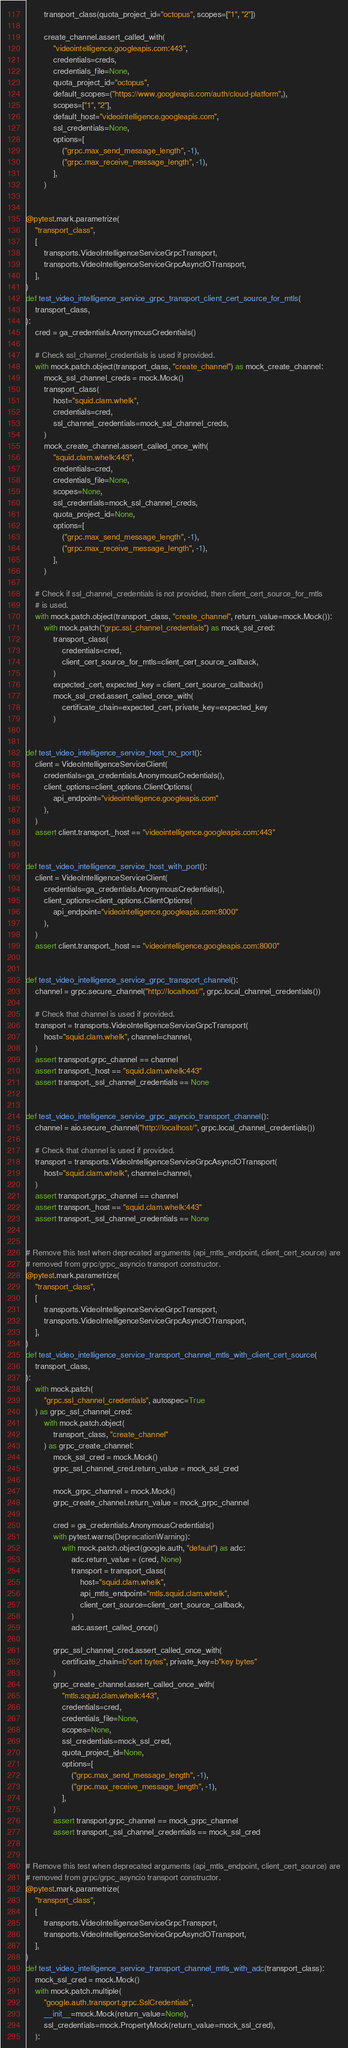Convert code to text. <code><loc_0><loc_0><loc_500><loc_500><_Python_>        transport_class(quota_project_id="octopus", scopes=["1", "2"])

        create_channel.assert_called_with(
            "videointelligence.googleapis.com:443",
            credentials=creds,
            credentials_file=None,
            quota_project_id="octopus",
            default_scopes=("https://www.googleapis.com/auth/cloud-platform",),
            scopes=["1", "2"],
            default_host="videointelligence.googleapis.com",
            ssl_credentials=None,
            options=[
                ("grpc.max_send_message_length", -1),
                ("grpc.max_receive_message_length", -1),
            ],
        )


@pytest.mark.parametrize(
    "transport_class",
    [
        transports.VideoIntelligenceServiceGrpcTransport,
        transports.VideoIntelligenceServiceGrpcAsyncIOTransport,
    ],
)
def test_video_intelligence_service_grpc_transport_client_cert_source_for_mtls(
    transport_class,
):
    cred = ga_credentials.AnonymousCredentials()

    # Check ssl_channel_credentials is used if provided.
    with mock.patch.object(transport_class, "create_channel") as mock_create_channel:
        mock_ssl_channel_creds = mock.Mock()
        transport_class(
            host="squid.clam.whelk",
            credentials=cred,
            ssl_channel_credentials=mock_ssl_channel_creds,
        )
        mock_create_channel.assert_called_once_with(
            "squid.clam.whelk:443",
            credentials=cred,
            credentials_file=None,
            scopes=None,
            ssl_credentials=mock_ssl_channel_creds,
            quota_project_id=None,
            options=[
                ("grpc.max_send_message_length", -1),
                ("grpc.max_receive_message_length", -1),
            ],
        )

    # Check if ssl_channel_credentials is not provided, then client_cert_source_for_mtls
    # is used.
    with mock.patch.object(transport_class, "create_channel", return_value=mock.Mock()):
        with mock.patch("grpc.ssl_channel_credentials") as mock_ssl_cred:
            transport_class(
                credentials=cred,
                client_cert_source_for_mtls=client_cert_source_callback,
            )
            expected_cert, expected_key = client_cert_source_callback()
            mock_ssl_cred.assert_called_once_with(
                certificate_chain=expected_cert, private_key=expected_key
            )


def test_video_intelligence_service_host_no_port():
    client = VideoIntelligenceServiceClient(
        credentials=ga_credentials.AnonymousCredentials(),
        client_options=client_options.ClientOptions(
            api_endpoint="videointelligence.googleapis.com"
        ),
    )
    assert client.transport._host == "videointelligence.googleapis.com:443"


def test_video_intelligence_service_host_with_port():
    client = VideoIntelligenceServiceClient(
        credentials=ga_credentials.AnonymousCredentials(),
        client_options=client_options.ClientOptions(
            api_endpoint="videointelligence.googleapis.com:8000"
        ),
    )
    assert client.transport._host == "videointelligence.googleapis.com:8000"


def test_video_intelligence_service_grpc_transport_channel():
    channel = grpc.secure_channel("http://localhost/", grpc.local_channel_credentials())

    # Check that channel is used if provided.
    transport = transports.VideoIntelligenceServiceGrpcTransport(
        host="squid.clam.whelk", channel=channel,
    )
    assert transport.grpc_channel == channel
    assert transport._host == "squid.clam.whelk:443"
    assert transport._ssl_channel_credentials == None


def test_video_intelligence_service_grpc_asyncio_transport_channel():
    channel = aio.secure_channel("http://localhost/", grpc.local_channel_credentials())

    # Check that channel is used if provided.
    transport = transports.VideoIntelligenceServiceGrpcAsyncIOTransport(
        host="squid.clam.whelk", channel=channel,
    )
    assert transport.grpc_channel == channel
    assert transport._host == "squid.clam.whelk:443"
    assert transport._ssl_channel_credentials == None


# Remove this test when deprecated arguments (api_mtls_endpoint, client_cert_source) are
# removed from grpc/grpc_asyncio transport constructor.
@pytest.mark.parametrize(
    "transport_class",
    [
        transports.VideoIntelligenceServiceGrpcTransport,
        transports.VideoIntelligenceServiceGrpcAsyncIOTransport,
    ],
)
def test_video_intelligence_service_transport_channel_mtls_with_client_cert_source(
    transport_class,
):
    with mock.patch(
        "grpc.ssl_channel_credentials", autospec=True
    ) as grpc_ssl_channel_cred:
        with mock.patch.object(
            transport_class, "create_channel"
        ) as grpc_create_channel:
            mock_ssl_cred = mock.Mock()
            grpc_ssl_channel_cred.return_value = mock_ssl_cred

            mock_grpc_channel = mock.Mock()
            grpc_create_channel.return_value = mock_grpc_channel

            cred = ga_credentials.AnonymousCredentials()
            with pytest.warns(DeprecationWarning):
                with mock.patch.object(google.auth, "default") as adc:
                    adc.return_value = (cred, None)
                    transport = transport_class(
                        host="squid.clam.whelk",
                        api_mtls_endpoint="mtls.squid.clam.whelk",
                        client_cert_source=client_cert_source_callback,
                    )
                    adc.assert_called_once()

            grpc_ssl_channel_cred.assert_called_once_with(
                certificate_chain=b"cert bytes", private_key=b"key bytes"
            )
            grpc_create_channel.assert_called_once_with(
                "mtls.squid.clam.whelk:443",
                credentials=cred,
                credentials_file=None,
                scopes=None,
                ssl_credentials=mock_ssl_cred,
                quota_project_id=None,
                options=[
                    ("grpc.max_send_message_length", -1),
                    ("grpc.max_receive_message_length", -1),
                ],
            )
            assert transport.grpc_channel == mock_grpc_channel
            assert transport._ssl_channel_credentials == mock_ssl_cred


# Remove this test when deprecated arguments (api_mtls_endpoint, client_cert_source) are
# removed from grpc/grpc_asyncio transport constructor.
@pytest.mark.parametrize(
    "transport_class",
    [
        transports.VideoIntelligenceServiceGrpcTransport,
        transports.VideoIntelligenceServiceGrpcAsyncIOTransport,
    ],
)
def test_video_intelligence_service_transport_channel_mtls_with_adc(transport_class):
    mock_ssl_cred = mock.Mock()
    with mock.patch.multiple(
        "google.auth.transport.grpc.SslCredentials",
        __init__=mock.Mock(return_value=None),
        ssl_credentials=mock.PropertyMock(return_value=mock_ssl_cred),
    ):</code> 